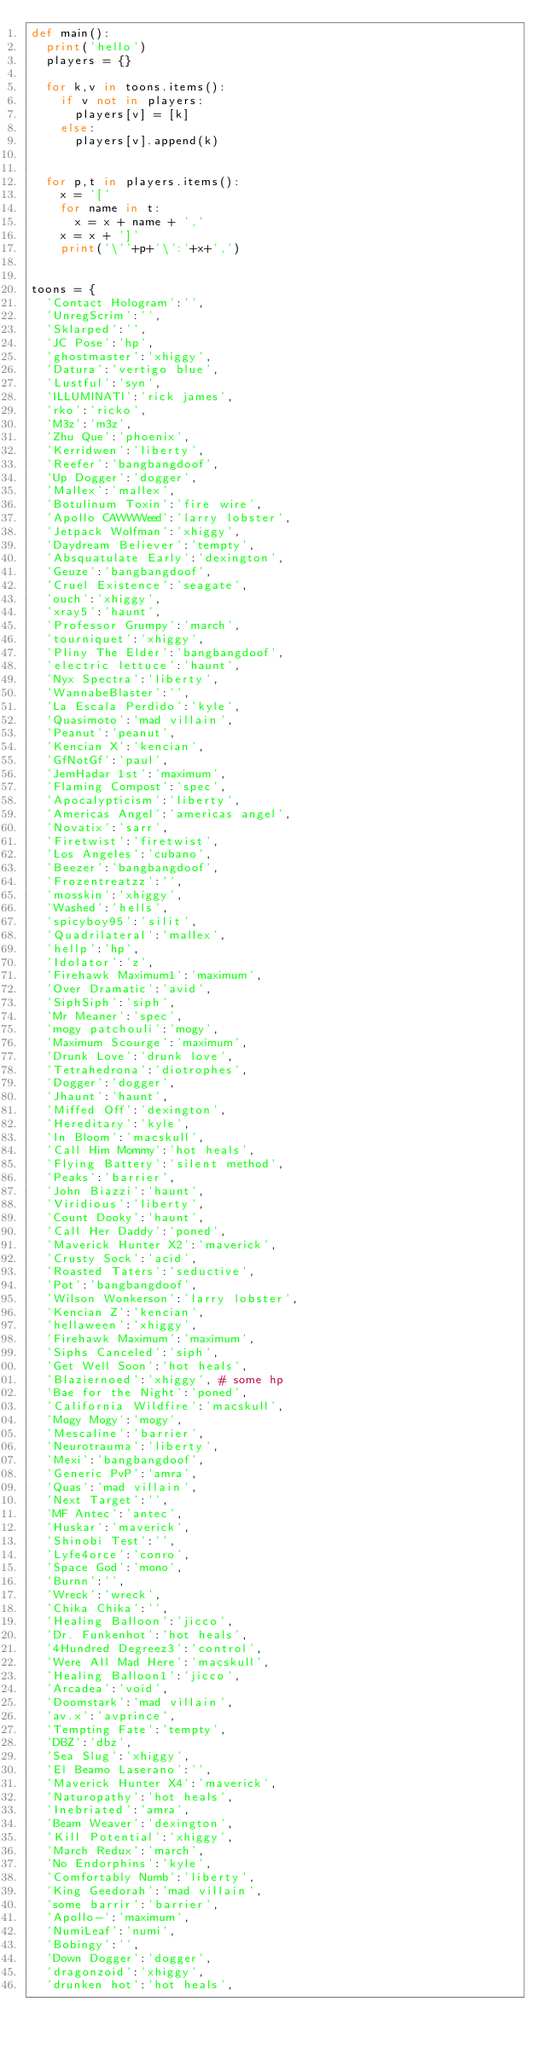Convert code to text. <code><loc_0><loc_0><loc_500><loc_500><_Python_>def main():
	print('hello')
	players = {}

	for k,v in toons.items():
		if v not in players:
			players[v] = [k]
		else:
			players[v].append(k)


	for p,t in players.items():
		x = '['
		for name in t:
			x = x + name + ','
		x = x + ']'
		print('\''+p+'\':'+x+',')


toons = {
	'Contact Hologram':'',
	'UnregScrim':'',
	'Sklarped':'',
	'JC Pose':'hp',
	'ghostmaster':'xhiggy',
	'Datura':'vertigo blue',
	'Lustful':'syn',
	'ILLUMlNATl':'rick james',
	'rko':'ricko',
	'M3z':'m3z',
	'Zhu Que':'phoenix',
	'Kerridwen':'liberty',
	'Reefer':'bangbangdoof',
	'Up Dogger':'dogger',
	'Mallex':'mallex',
	'Botulinum Toxin':'fire wire',
	'Apollo CAWWWeed':'larry lobster',
	'Jetpack Wolfman':'xhiggy',
	'Daydream Believer':'tempty',
	'Absquatulate Early':'dexington',
	'Geuze':'bangbangdoof',
	'Cruel Existence':'seagate',
	'ouch':'xhiggy',
	'xray5':'haunt',
	'Professor Grumpy':'march',
	'tourniquet':'xhiggy',
	'Pliny The Elder':'bangbangdoof',
	'electric lettuce':'haunt',
	'Nyx Spectra':'liberty',
	'WannabeBlaster':'',
	'La Escala Perdido':'kyle',
	'Quasimoto':'mad villain',
	'Peanut':'peanut',
	'Kencian X':'kencian',
	'GfNotGf':'paul',
	'JemHadar 1st':'maximum',
	'Flaming Compost':'spec',
	'Apocalypticism':'liberty',
	'Americas Angel':'americas angel',
	'Novatix':'sarr',
	'Firetwist':'firetwist',
	'Los Angeles':'cubano',
	'Beezer':'bangbangdoof',
	'Frozentreatzz':'',
	'mosskin':'xhiggy',
	'Washed':'hells',
	'spicyboy95':'silit',
	'Quadrilateral':'mallex',
	'hellp':'hp',
	'Idolator':'z',
	'Firehawk Maximum1':'maximum',
	'Over Dramatic':'avid',
	'SiphSiph':'siph',
	'Mr Meaner':'spec',
	'mogy patchouli':'mogy',
	'Maximum Scourge':'maximum',
	'Drunk Love':'drunk love',
	'Tetrahedrona':'diotrophes',
	'Dogger':'dogger',
	'Jhaunt':'haunt',
	'Miffed Off':'dexington',
	'Hereditary':'kyle',
	'In Bloom':'macskull',
	'Call Him Mommy':'hot heals',
	'Flying Battery':'silent method',
	'Peaks':'barrier',
	'John Biazzi':'haunt',
	'Viridious':'liberty',
	'Count Dooky':'haunt',
	'Call Her Daddy':'poned',
	'Maverick Hunter X2':'maverick',
	'Crusty Sock':'acid',
	'Roasted Taters':'seductive',
	'Pot':'bangbangdoof',
	'Wilson Wonkerson':'larry lobster',
	'Kencian Z':'kencian',
	'hellaween':'xhiggy',
	'Firehawk Maximum':'maximum',
	'Siphs Canceled':'siph',
	'Get Well Soon':'hot heals',
	'Blaziernoed':'xhiggy', # some hp
	'Bae for the Night':'poned',
	'California Wildfire':'macskull',
	'Mogy Mogy':'mogy',
	'Mescaline':'barrier',
	'Neurotrauma':'liberty',
	'Mexi':'bangbangdoof',
	'Generic PvP':'amra',
	'Quas':'mad villain',
	'Next Target':'',
	'MF Antec':'antec',
	'Huskar':'maverick',
	'Shinobi Test':'',
	'Lyfe4orce':'conro',
	'Space God':'mono',
	'Burnn':'',
	'Wreck':'wreck',
	'Chika Chika':'',
	'Healing Balloon':'jicco',
	'Dr. Funkenhot':'hot heals',
	'4Hundred Degreez3':'control',
	'Were All Mad Here':'macskull',
	'Healing Balloon1':'jicco',
	'Arcadea':'void',
	'Doomstark':'mad villain',
	'av.x':'avprince',
	'Tempting Fate':'tempty',
	'DBZ':'dbz',
	'Sea Slug':'xhiggy',
	'El Beamo Laserano':'',
	'Maverick Hunter X4':'maverick',
	'Naturopathy':'hot heals',
	'Inebriated':'amra',
	'Beam Weaver':'dexington',
	'Kill Potential':'xhiggy',
	'March Redux':'march',
	'No Endorphins':'kyle',
	'Comfortably Numb':'liberty',
	'King Geedorah':'mad villain',
	'some barrir':'barrier',
	'Apollo-':'maximum',
	'NumiLeaf':'numi',
	'Bobingy':'',
	'Down Dogger':'dogger',
	'dragonzoid':'xhiggy',
	'drunken hot':'hot heals',</code> 